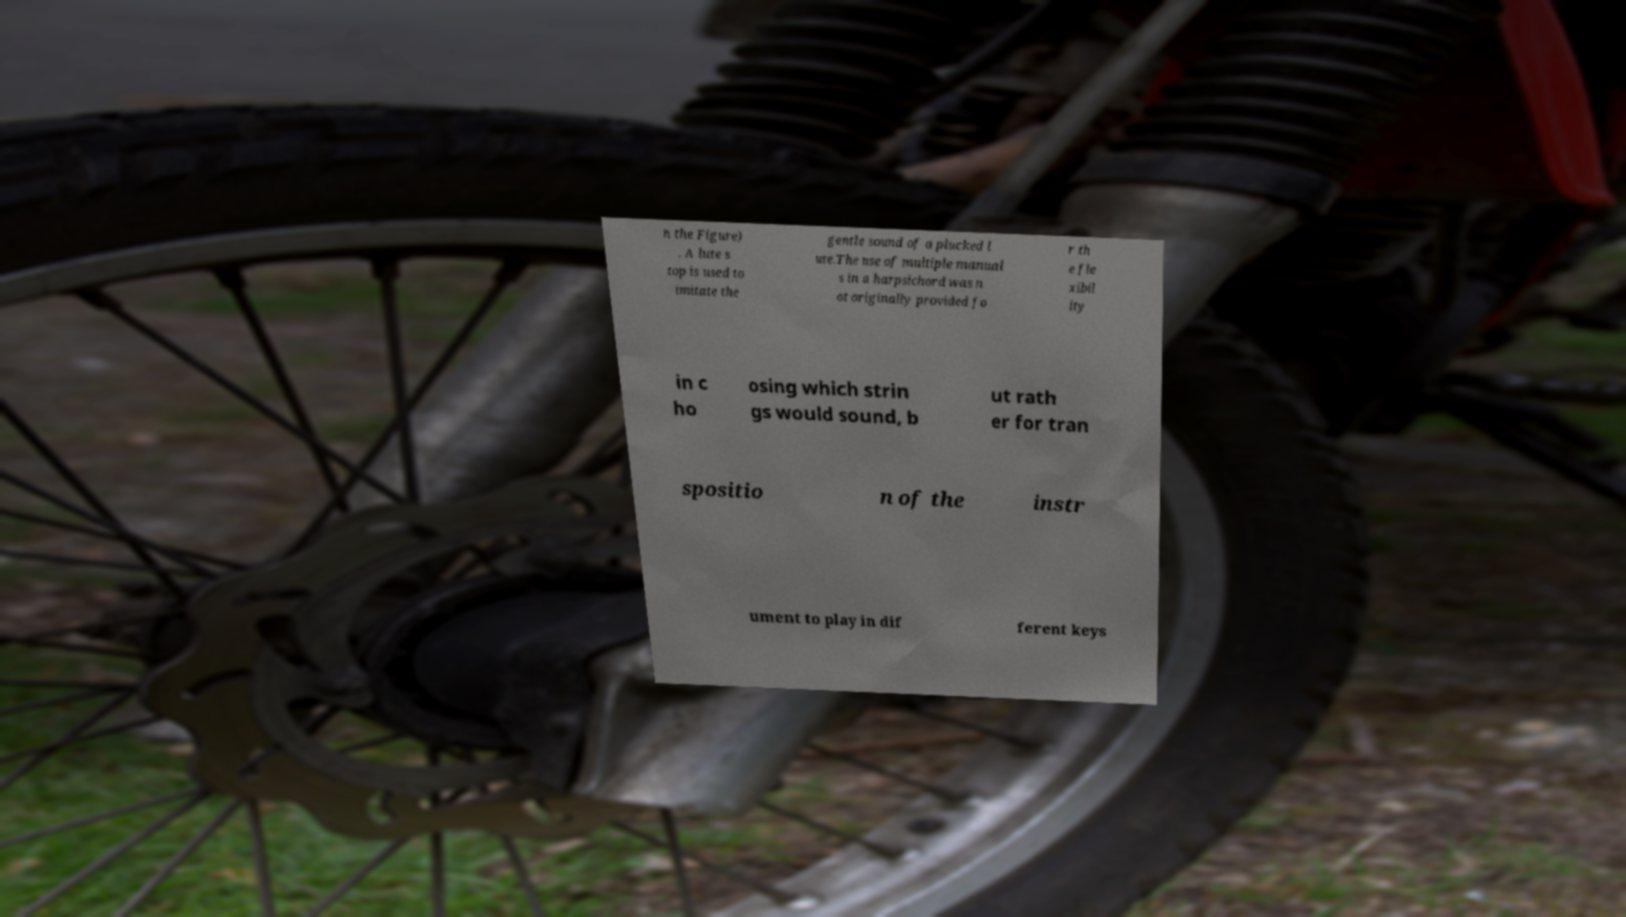What messages or text are displayed in this image? I need them in a readable, typed format. n the Figure) . A lute s top is used to imitate the gentle sound of a plucked l ute.The use of multiple manual s in a harpsichord was n ot originally provided fo r th e fle xibil ity in c ho osing which strin gs would sound, b ut rath er for tran spositio n of the instr ument to play in dif ferent keys 